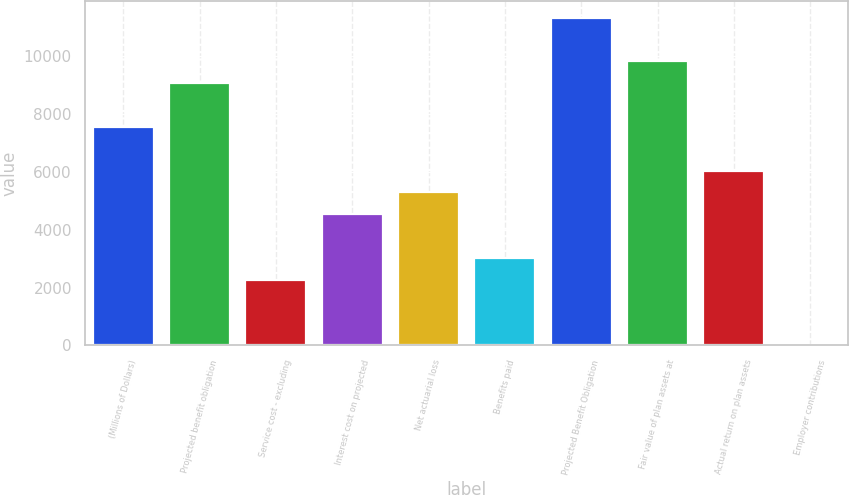Convert chart. <chart><loc_0><loc_0><loc_500><loc_500><bar_chart><fcel>(Millions of Dollars)<fcel>Projected benefit obligation<fcel>Service cost - excluding<fcel>Interest cost on projected<fcel>Net actuarial loss<fcel>Benefits paid<fcel>Projected Benefit Obligation<fcel>Fair value of plan assets at<fcel>Actual return on plan assets<fcel>Employer contributions<nl><fcel>7557<fcel>9068<fcel>2268.5<fcel>4535<fcel>5290.5<fcel>3024<fcel>11334.5<fcel>9823.5<fcel>6046<fcel>2<nl></chart> 